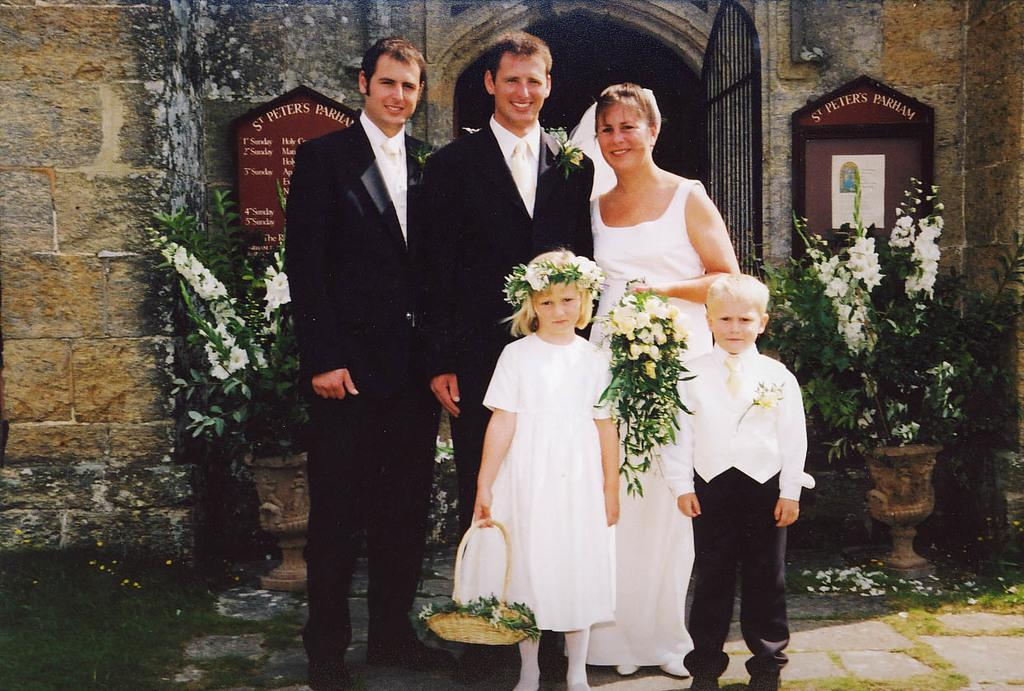How many people and kids are in the image? There are three persons and two kids in the image. What are the people and kids doing in the image? The persons and kids are standing. What can be seen in the background of the image? There is a building and two flower vases in the background of the image. What type of flower is growing in the territory of the deer in the image? There are no flowers or deer present in the image. 